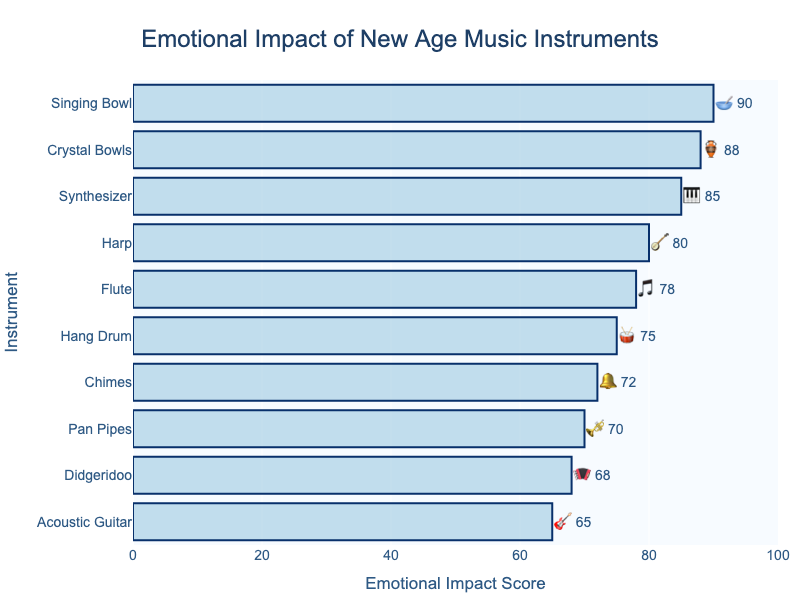What is the title of the chart? The title is located at the top of the chart and reads "Emotional Impact of New Age Music Instruments."
Answer: Emotional Impact of New Age Music Instruments Which instrument has the highest emotional impact score? The instrument with the highest bar on the horizontal bar chart represents the highest impact score, which is the Singing Bowl with a score of 90.
Answer: Singing Bowl How many instruments have an emotional impact score above 80? Identify the bars that extend beyond the 80 mark on the x-axis. Synthesizer, Harp, Crystal Bowls, and Singing Bowl all score above 80.
Answer: 4 What is the emotional impact score of the Acoustic Guitar? Locate the Acoustic Guitar bar on the chart and read off its corresponding x-axis value of 65.
Answer: 65 Which instruments have emotional impact scores between 70 and 80? Find the bars whose lengths indicate scores between 70 and 80. These are the Flute, Hang Drum, and Pan Pipes.
Answer: 3 Compare the emotional impact score of the Didgeridoo and the Flute. Which one is higher? Locate the Didgeridoo and Flute bars and compare their lengths. The Flute's score (78) is higher than the Didgeridoo's score (68).
Answer: Flute What is the average emotional impact score of the listed instruments? Add all the scores together (85 + 78 + 72 + 90 + 65 + 80 + 75 + 70 + 88 + 68) = 771, then divide by the number of instruments (10), so the average score is 771 / 10 = 77.1.
Answer: 77.1 Which instrument scores just below the Harp in emotional impact? First, find the Harp bar with its score of 80. The next instrument below is the Flute with a score of 78.
Answer: Flute What is the median emotional impact score for the instruments? List the scores in numeric order (65, 68, 70, 72, 75, 78, 80, 85, 88, 90). With 10 instruments, the median is the average of the 5th and 6th scores: (75+78)/2 = 76.5.
Answer: 76.5 Which instrument has the second lowest emotional impact score? Sort the scores from lowest to highest and find the second score, which is 68 for the Didgeridoo.
Answer: Didgeridoo 